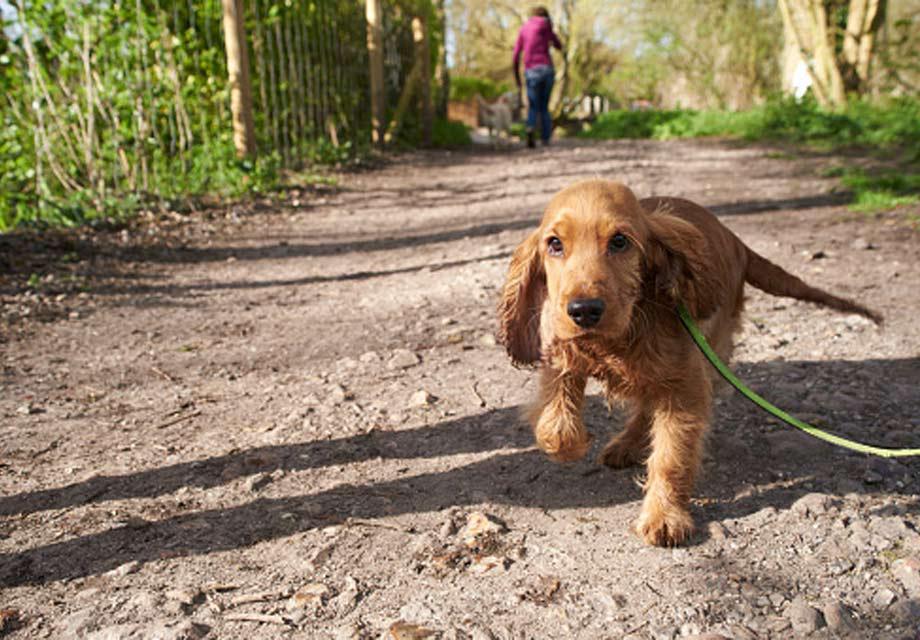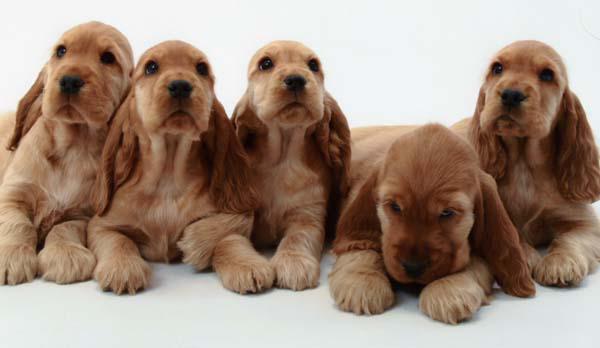The first image is the image on the left, the second image is the image on the right. Assess this claim about the two images: "There are equal amount of dogs on the left image as the right image.". Correct or not? Answer yes or no. No. The first image is the image on the left, the second image is the image on the right. For the images shown, is this caption "There are at least three dogs in the right image." true? Answer yes or no. Yes. 